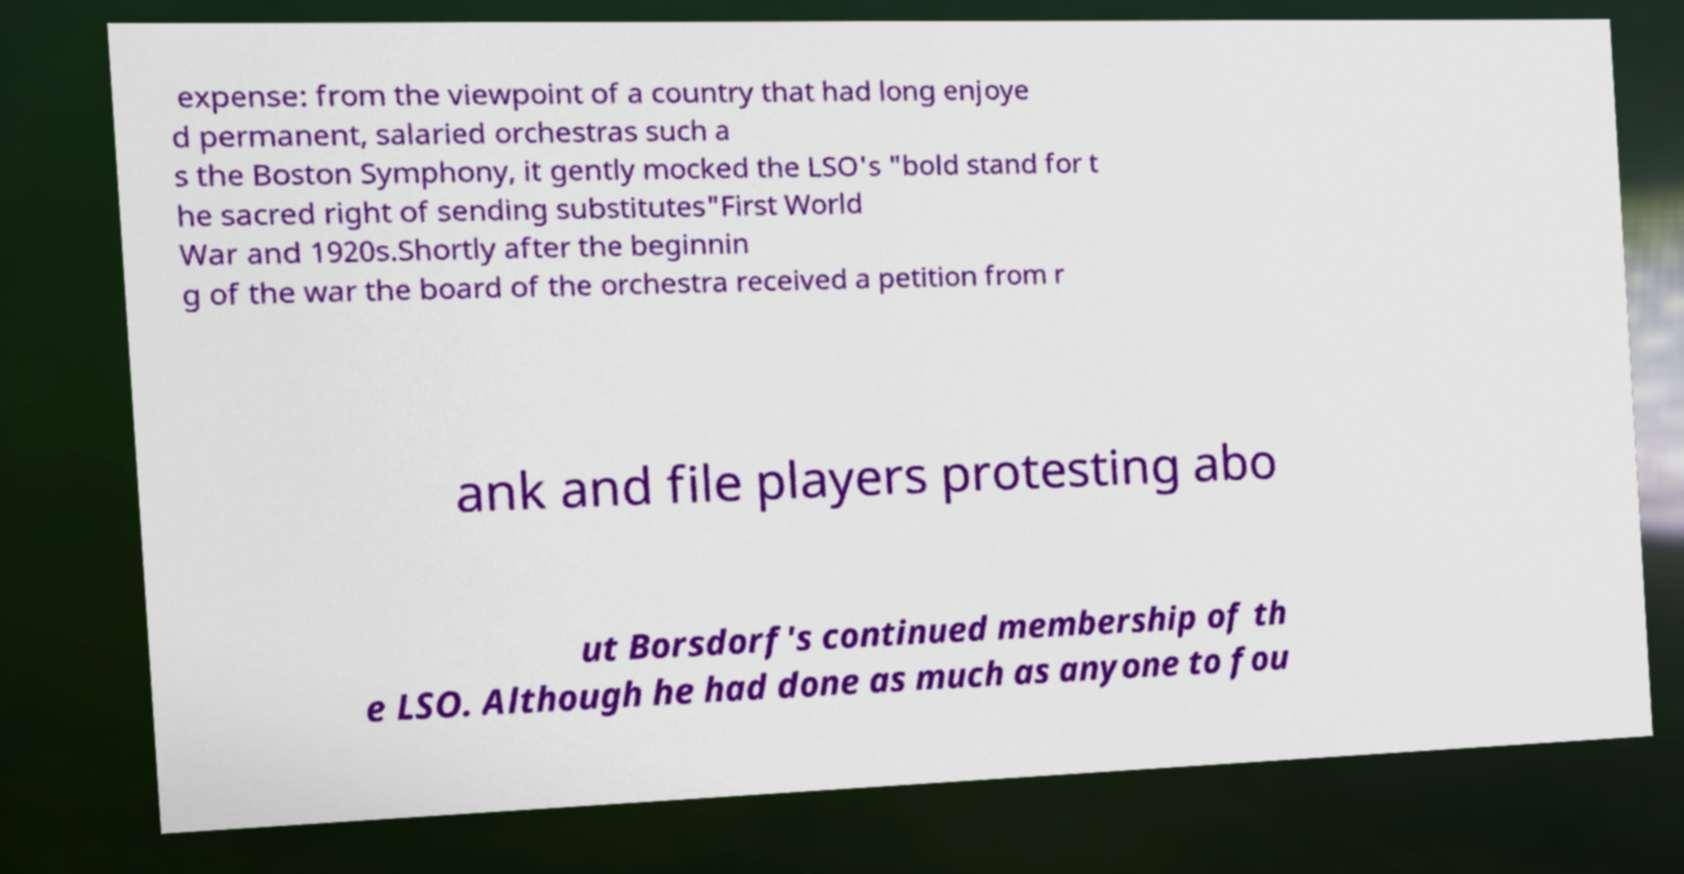Could you assist in decoding the text presented in this image and type it out clearly? expense: from the viewpoint of a country that had long enjoye d permanent, salaried orchestras such a s the Boston Symphony, it gently mocked the LSO's "bold stand for t he sacred right of sending substitutes"First World War and 1920s.Shortly after the beginnin g of the war the board of the orchestra received a petition from r ank and file players protesting abo ut Borsdorf's continued membership of th e LSO. Although he had done as much as anyone to fou 